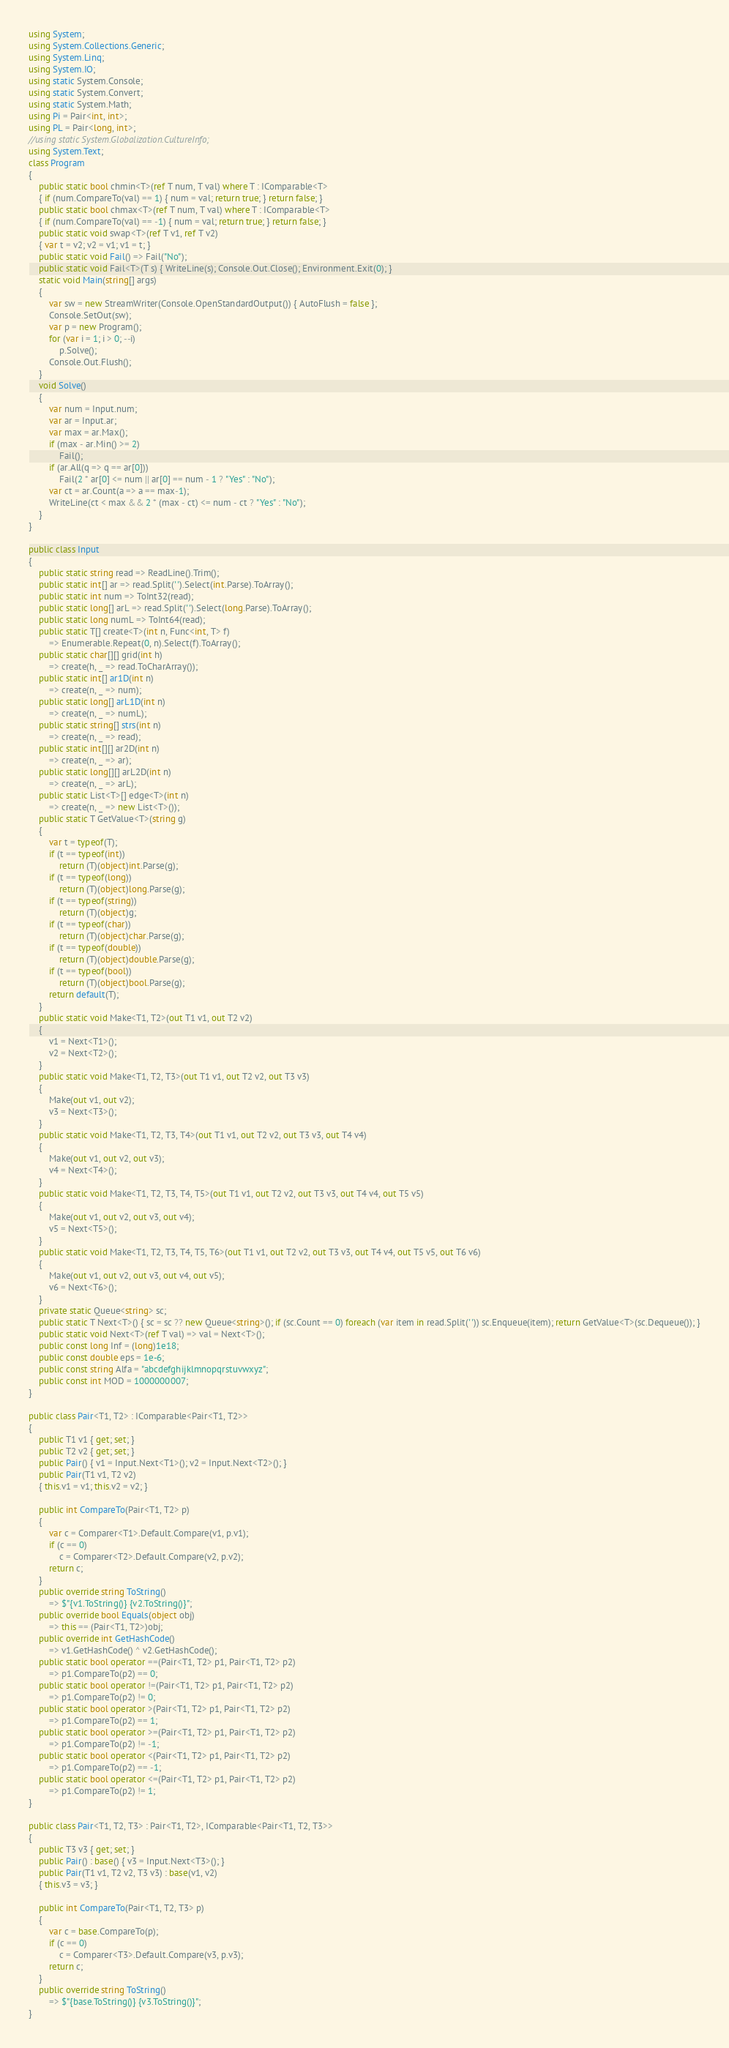<code> <loc_0><loc_0><loc_500><loc_500><_C#_>using System;
using System.Collections.Generic;
using System.Linq;
using System.IO;
using static System.Console;
using static System.Convert;
using static System.Math;
using Pi = Pair<int, int>;
using PL = Pair<long, int>;
//using static System.Globalization.CultureInfo;
using System.Text;
class Program
{
    public static bool chmin<T>(ref T num, T val) where T : IComparable<T>
    { if (num.CompareTo(val) == 1) { num = val; return true; } return false; }
    public static bool chmax<T>(ref T num, T val) where T : IComparable<T>
    { if (num.CompareTo(val) == -1) { num = val; return true; } return false; }
    public static void swap<T>(ref T v1, ref T v2)
    { var t = v2; v2 = v1; v1 = t; }
    public static void Fail() => Fail("No");
    public static void Fail<T>(T s) { WriteLine(s); Console.Out.Close(); Environment.Exit(0); }
    static void Main(string[] args)
    {
        var sw = new StreamWriter(Console.OpenStandardOutput()) { AutoFlush = false };
        Console.SetOut(sw);
        var p = new Program();
        for (var i = 1; i > 0; --i) 
            p.Solve();
        Console.Out.Flush();
    }
    void Solve()
    {
        var num = Input.num;
        var ar = Input.ar;
        var max = ar.Max();
        if (max - ar.Min() >= 2)
            Fail();
        if (ar.All(q => q == ar[0]))
            Fail(2 * ar[0] <= num || ar[0] == num - 1 ? "Yes" : "No");
        var ct = ar.Count(a => a == max-1);
        WriteLine(ct < max && 2 * (max - ct) <= num - ct ? "Yes" : "No");
    }
}

public class Input
{
    public static string read => ReadLine().Trim();
    public static int[] ar => read.Split(' ').Select(int.Parse).ToArray();
    public static int num => ToInt32(read);
    public static long[] arL => read.Split(' ').Select(long.Parse).ToArray();
    public static long numL => ToInt64(read);
    public static T[] create<T>(int n, Func<int, T> f)
        => Enumerable.Repeat(0, n).Select(f).ToArray();
    public static char[][] grid(int h)
        => create(h, _ => read.ToCharArray());
    public static int[] ar1D(int n)
        => create(n, _ => num);
    public static long[] arL1D(int n)
        => create(n, _ => numL);
    public static string[] strs(int n)
        => create(n, _ => read);
    public static int[][] ar2D(int n)
        => create(n, _ => ar);
    public static long[][] arL2D(int n)
        => create(n, _ => arL);
    public static List<T>[] edge<T>(int n)
        => create(n, _ => new List<T>());
    public static T GetValue<T>(string g)
    {
        var t = typeof(T);
        if (t == typeof(int))
            return (T)(object)int.Parse(g);
        if (t == typeof(long))
            return (T)(object)long.Parse(g);
        if (t == typeof(string))
            return (T)(object)g;
        if (t == typeof(char))
            return (T)(object)char.Parse(g);
        if (t == typeof(double))
            return (T)(object)double.Parse(g);
        if (t == typeof(bool))
            return (T)(object)bool.Parse(g);
        return default(T);
    }
    public static void Make<T1, T2>(out T1 v1, out T2 v2)
    {
        v1 = Next<T1>();
        v2 = Next<T2>();
    }
    public static void Make<T1, T2, T3>(out T1 v1, out T2 v2, out T3 v3)
    {
        Make(out v1, out v2);
        v3 = Next<T3>();
    }
    public static void Make<T1, T2, T3, T4>(out T1 v1, out T2 v2, out T3 v3, out T4 v4)
    {
        Make(out v1, out v2, out v3);
        v4 = Next<T4>();
    }
    public static void Make<T1, T2, T3, T4, T5>(out T1 v1, out T2 v2, out T3 v3, out T4 v4, out T5 v5)
    {
        Make(out v1, out v2, out v3, out v4);
        v5 = Next<T5>();
    }
    public static void Make<T1, T2, T3, T4, T5, T6>(out T1 v1, out T2 v2, out T3 v3, out T4 v4, out T5 v5, out T6 v6)
    {
        Make(out v1, out v2, out v3, out v4, out v5);
        v6 = Next<T6>();
    }
    private static Queue<string> sc;
    public static T Next<T>() { sc = sc ?? new Queue<string>(); if (sc.Count == 0) foreach (var item in read.Split(' ')) sc.Enqueue(item); return GetValue<T>(sc.Dequeue()); }
    public static void Next<T>(ref T val) => val = Next<T>();
    public const long Inf = (long)1e18;
    public const double eps = 1e-6;
    public const string Alfa = "abcdefghijklmnopqrstuvwxyz";
    public const int MOD = 1000000007;
}

public class Pair<T1, T2> : IComparable<Pair<T1, T2>>
{
    public T1 v1 { get; set; }
    public T2 v2 { get; set; }
    public Pair() { v1 = Input.Next<T1>(); v2 = Input.Next<T2>(); }
    public Pair(T1 v1, T2 v2)
    { this.v1 = v1; this.v2 = v2; }

    public int CompareTo(Pair<T1, T2> p)
    {
        var c = Comparer<T1>.Default.Compare(v1, p.v1);
        if (c == 0)
            c = Comparer<T2>.Default.Compare(v2, p.v2);
        return c;
    }
    public override string ToString()
        => $"{v1.ToString()} {v2.ToString()}";
    public override bool Equals(object obj)
        => this == (Pair<T1, T2>)obj;
    public override int GetHashCode()
        => v1.GetHashCode() ^ v2.GetHashCode();
    public static bool operator ==(Pair<T1, T2> p1, Pair<T1, T2> p2)
        => p1.CompareTo(p2) == 0;
    public static bool operator !=(Pair<T1, T2> p1, Pair<T1, T2> p2)
        => p1.CompareTo(p2) != 0;
    public static bool operator >(Pair<T1, T2> p1, Pair<T1, T2> p2)
        => p1.CompareTo(p2) == 1;
    public static bool operator >=(Pair<T1, T2> p1, Pair<T1, T2> p2)
        => p1.CompareTo(p2) != -1;
    public static bool operator <(Pair<T1, T2> p1, Pair<T1, T2> p2)
        => p1.CompareTo(p2) == -1;
    public static bool operator <=(Pair<T1, T2> p1, Pair<T1, T2> p2)
        => p1.CompareTo(p2) != 1;
}

public class Pair<T1, T2, T3> : Pair<T1, T2>, IComparable<Pair<T1, T2, T3>>
{
    public T3 v3 { get; set; }
    public Pair() : base() { v3 = Input.Next<T3>(); }
    public Pair(T1 v1, T2 v2, T3 v3) : base(v1, v2)
    { this.v3 = v3; }

    public int CompareTo(Pair<T1, T2, T3> p)
    {
        var c = base.CompareTo(p);
        if (c == 0)
            c = Comparer<T3>.Default.Compare(v3, p.v3);
        return c;
    }
    public override string ToString()
        => $"{base.ToString()} {v3.ToString()}";
}
</code> 